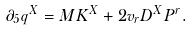Convert formula to latex. <formula><loc_0><loc_0><loc_500><loc_500>\partial _ { 5 } q ^ { X } = M K ^ { X } + 2 v _ { r } D ^ { X } P ^ { r } .</formula> 